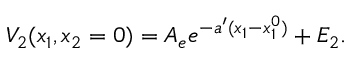Convert formula to latex. <formula><loc_0><loc_0><loc_500><loc_500>V _ { 2 } ( x _ { 1 } , x _ { 2 } = 0 ) = A _ { e } e ^ { - a ^ { \prime } ( x _ { 1 } - x _ { 1 } ^ { 0 } ) } + E _ { 2 } .</formula> 